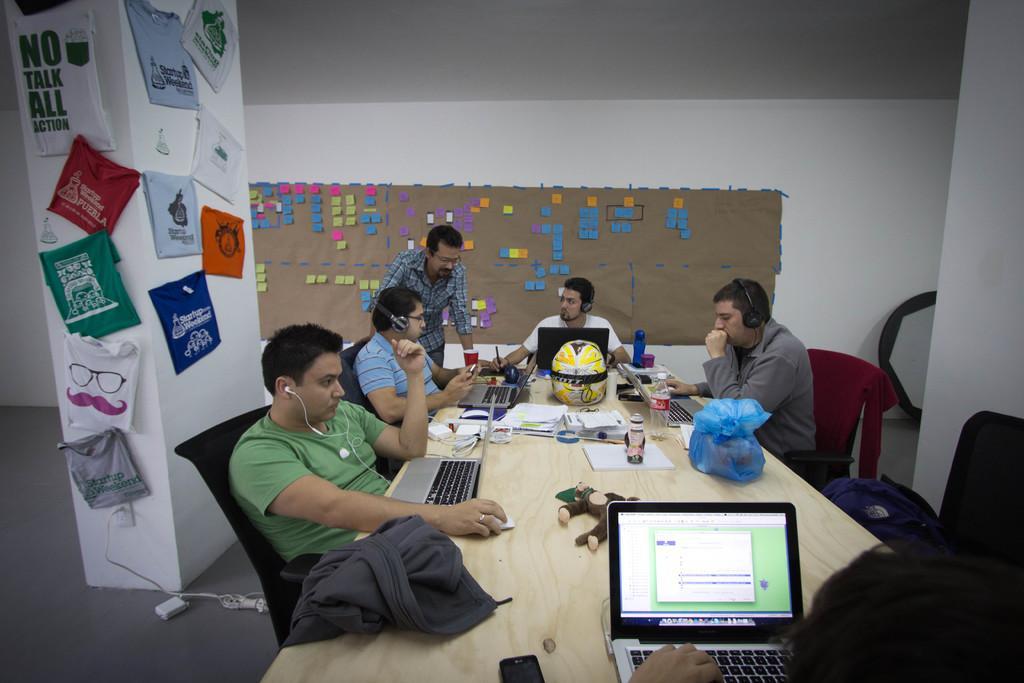Describe this image in one or two sentences. This picture shows few men seated on the chairs and we see a man standing and we see few of them were headsets and we see a man wore ear phones and we see laptops on the table and few bottles and books and papers and a helmet, Carry bag and a soft toy, Mobile phone on the table and we see clothes hanging to the pillar and we see board on the back with sticky papers on it. 